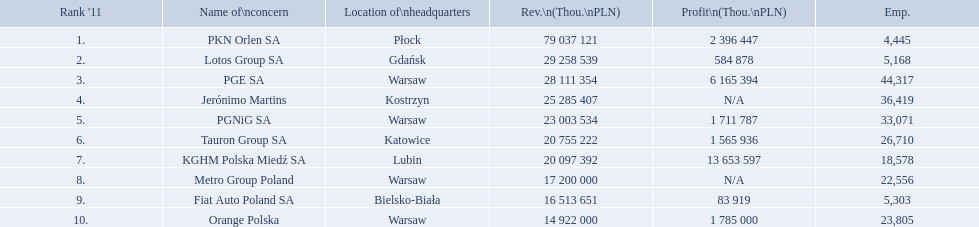What are the names of the major companies of poland? PKN Orlen SA, Lotos Group SA, PGE SA, Jerónimo Martins, PGNiG SA, Tauron Group SA, KGHM Polska Miedź SA, Metro Group Poland, Fiat Auto Poland SA, Orange Polska. What are the revenues of those companies in thou. pln? PKN Orlen SA, 79 037 121, Lotos Group SA, 29 258 539, PGE SA, 28 111 354, Jerónimo Martins, 25 285 407, PGNiG SA, 23 003 534, Tauron Group SA, 20 755 222, KGHM Polska Miedź SA, 20 097 392, Metro Group Poland, 17 200 000, Fiat Auto Poland SA, 16 513 651, Orange Polska, 14 922 000. Which of these revenues is greater than 75 000 000 thou. pln? 79 037 121. Which company has a revenue equal to 79 037 121 thou pln? PKN Orlen SA. What is the number of employees that work for pkn orlen sa in poland? 4,445. What number of employees work for lotos group sa? 5,168. How many people work for pgnig sa? 33,071. 